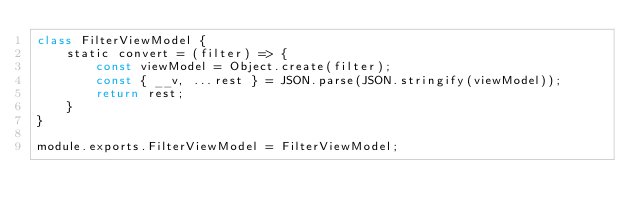<code> <loc_0><loc_0><loc_500><loc_500><_JavaScript_>class FilterViewModel {   
    static convert = (filter) => {
        const viewModel = Object.create(filter);
        const { __v, ...rest } = JSON.parse(JSON.stringify(viewModel));
        return rest;
    }
}

module.exports.FilterViewModel = FilterViewModel;</code> 